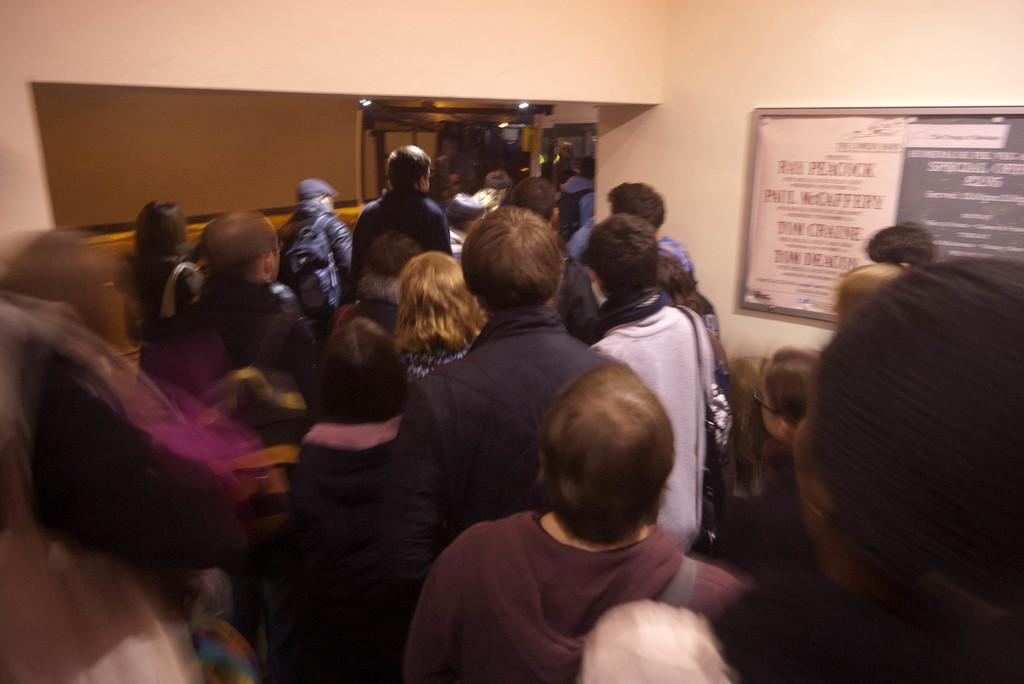Who or what can be seen in the image? There are people in the image. What is on the wall in the image? There is a board on the wall in the image. What can be seen in the background of the image? There are lights visible in the background of the image. What type of coat is hanging on the rail in the image? There is no rail or coat present in the image. How does the pump function in the image? There is no pump present in the image. 